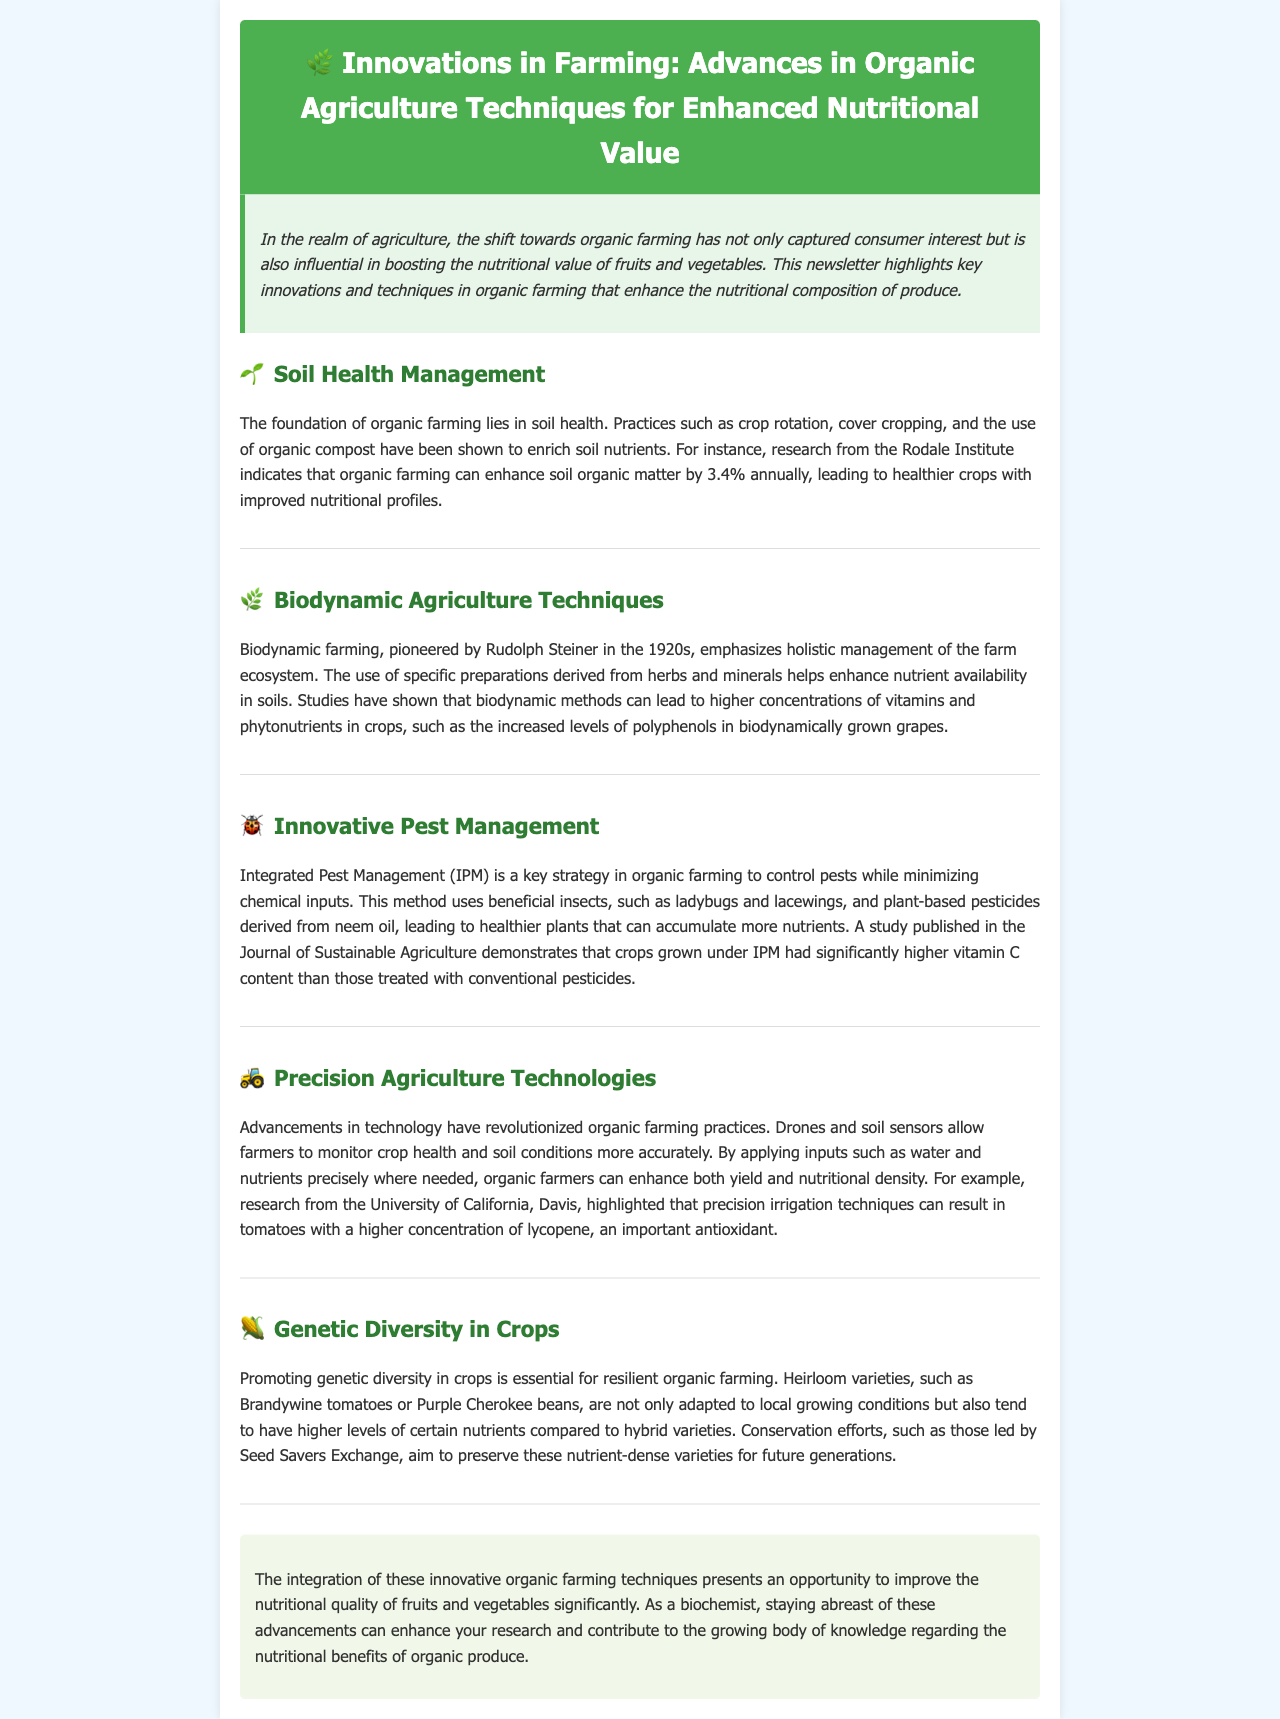What is the annual increase in soil organic matter according to the Rodale Institute? The document mentions that organic farming can enhance soil organic matter by 3.4% annually.
Answer: 3.4% Who pioneered biodynamic farming? The document states that biodynamic farming was pioneered by Rudolph Steiner in the 1920s.
Answer: Rudolph Steiner What is a major focus of Integrated Pest Management in organic farming? The document describes Integrated Pest Management (IPM) as a key strategy to control pests while minimizing chemical inputs.
Answer: Controlling pests What nutrient is highlighted to be higher in crops grown under Integrated Pest Management? A study indicates that crops under IPM had significantly higher vitamin C content.
Answer: Vitamin C What technology uses drones in organic farming? The document mentions that precision agriculture technologies utilize drones and soil sensors for monitoring crop health.
Answer: Precision agriculture What type of crop varieties tend to have higher levels of certain nutrients? The document points out that heirloom varieties, such as Brandywine tomatoes or Purple Cherokee beans, have higher nutrient levels.
Answer: Heirloom varieties What organization is mentioned for conservation efforts of nutrient-dense varieties? The document refers to Seed Savers Exchange as the organization leading conservation efforts.
Answer: Seed Savers Exchange Which antioxidant concentration can increase due to precision irrigation techniques? The document highlights that precision irrigation can result in a higher concentration of lycopene in tomatoes.
Answer: Lycopene 